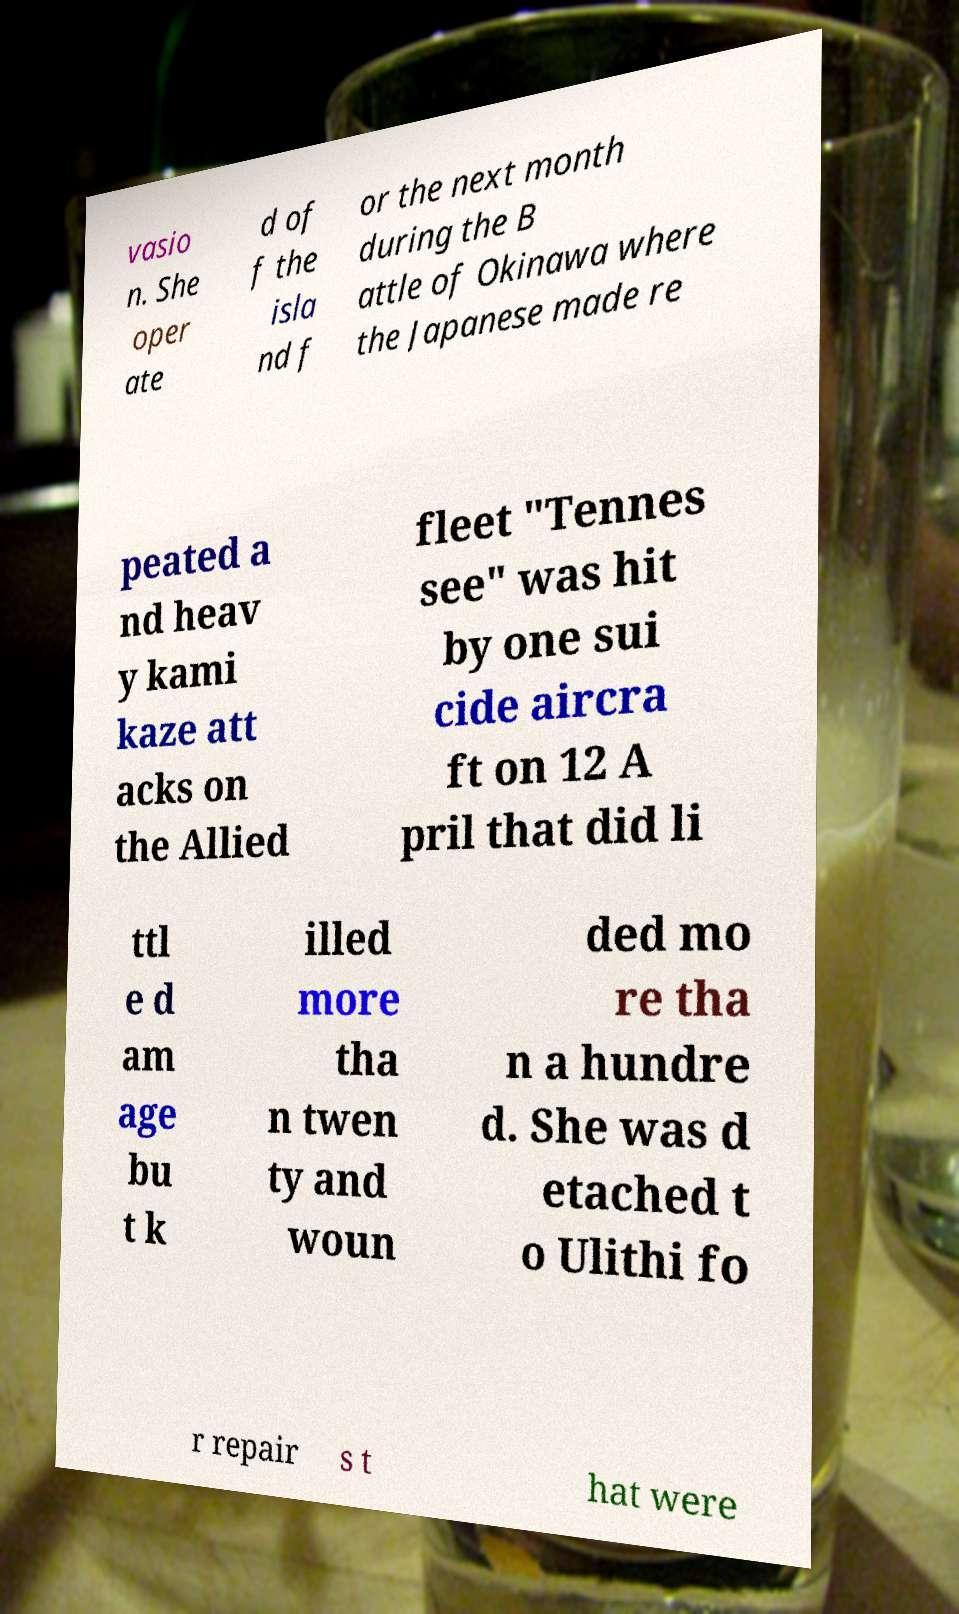I need the written content from this picture converted into text. Can you do that? vasio n. She oper ate d of f the isla nd f or the next month during the B attle of Okinawa where the Japanese made re peated a nd heav y kami kaze att acks on the Allied fleet "Tennes see" was hit by one sui cide aircra ft on 12 A pril that did li ttl e d am age bu t k illed more tha n twen ty and woun ded mo re tha n a hundre d. She was d etached t o Ulithi fo r repair s t hat were 